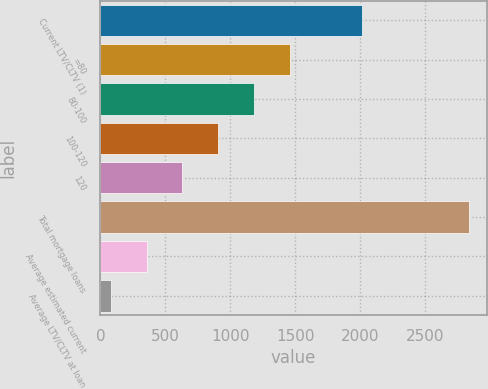<chart> <loc_0><loc_0><loc_500><loc_500><bar_chart><fcel>Current LTV/CLTV (1)<fcel>=80<fcel>80-100<fcel>100-120<fcel>120<fcel>Total mortgage loans<fcel>Average estimated current<fcel>Average LTV/CLTV at loan<nl><fcel>2014<fcel>1457<fcel>1181.6<fcel>906.2<fcel>630.8<fcel>2834<fcel>355.4<fcel>80<nl></chart> 